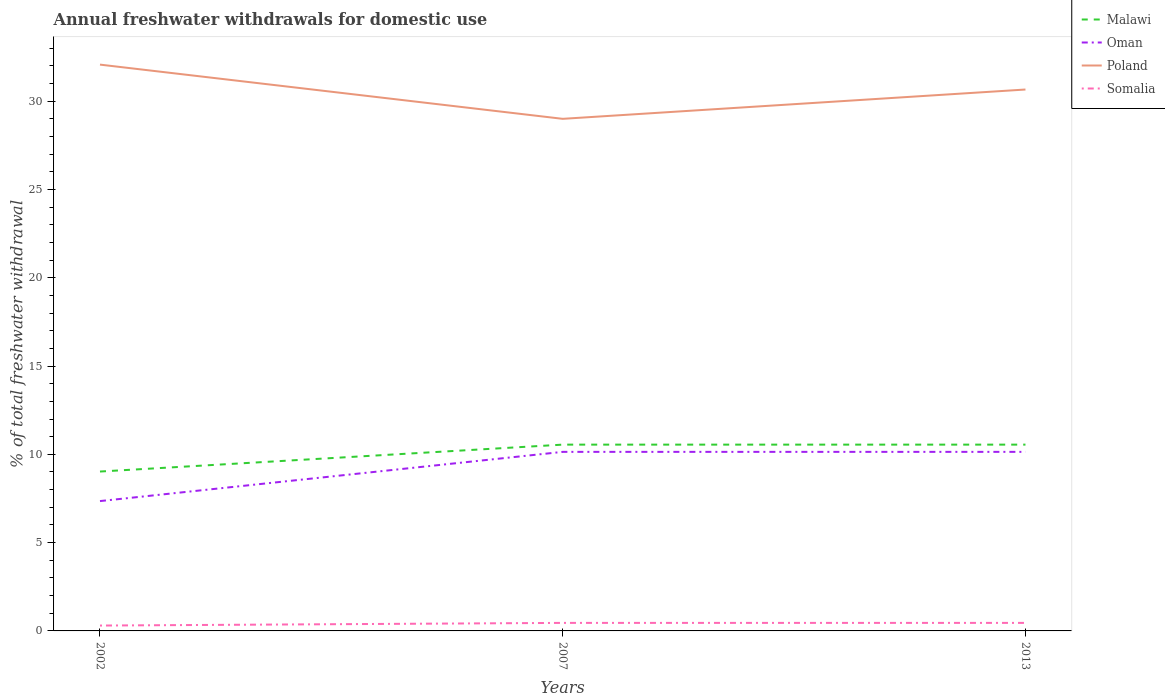Does the line corresponding to Poland intersect with the line corresponding to Oman?
Give a very brief answer. No. Is the number of lines equal to the number of legend labels?
Your answer should be very brief. Yes. Across all years, what is the maximum total annual withdrawals from freshwater in Somalia?
Your response must be concise. 0.3. In which year was the total annual withdrawals from freshwater in Malawi maximum?
Your answer should be compact. 2002. What is the difference between the highest and the second highest total annual withdrawals from freshwater in Somalia?
Your response must be concise. 0.15. Is the total annual withdrawals from freshwater in Malawi strictly greater than the total annual withdrawals from freshwater in Poland over the years?
Offer a very short reply. Yes. How many lines are there?
Keep it short and to the point. 4. Does the graph contain any zero values?
Offer a terse response. No. How are the legend labels stacked?
Provide a short and direct response. Vertical. What is the title of the graph?
Keep it short and to the point. Annual freshwater withdrawals for domestic use. Does "Tajikistan" appear as one of the legend labels in the graph?
Your answer should be very brief. No. What is the label or title of the X-axis?
Offer a terse response. Years. What is the label or title of the Y-axis?
Your answer should be compact. % of total freshwater withdrawal. What is the % of total freshwater withdrawal of Malawi in 2002?
Give a very brief answer. 9.03. What is the % of total freshwater withdrawal in Oman in 2002?
Ensure brevity in your answer.  7.35. What is the % of total freshwater withdrawal in Poland in 2002?
Give a very brief answer. 32.07. What is the % of total freshwater withdrawal in Somalia in 2002?
Ensure brevity in your answer.  0.3. What is the % of total freshwater withdrawal of Malawi in 2007?
Your answer should be compact. 10.55. What is the % of total freshwater withdrawal of Oman in 2007?
Make the answer very short. 10.14. What is the % of total freshwater withdrawal in Somalia in 2007?
Your response must be concise. 0.45. What is the % of total freshwater withdrawal of Malawi in 2013?
Your response must be concise. 10.55. What is the % of total freshwater withdrawal in Oman in 2013?
Ensure brevity in your answer.  10.14. What is the % of total freshwater withdrawal in Poland in 2013?
Your answer should be compact. 30.66. What is the % of total freshwater withdrawal of Somalia in 2013?
Provide a short and direct response. 0.45. Across all years, what is the maximum % of total freshwater withdrawal in Malawi?
Offer a very short reply. 10.55. Across all years, what is the maximum % of total freshwater withdrawal of Oman?
Offer a very short reply. 10.14. Across all years, what is the maximum % of total freshwater withdrawal in Poland?
Your answer should be compact. 32.07. Across all years, what is the maximum % of total freshwater withdrawal of Somalia?
Make the answer very short. 0.45. Across all years, what is the minimum % of total freshwater withdrawal in Malawi?
Keep it short and to the point. 9.03. Across all years, what is the minimum % of total freshwater withdrawal in Oman?
Offer a very short reply. 7.35. Across all years, what is the minimum % of total freshwater withdrawal of Somalia?
Give a very brief answer. 0.3. What is the total % of total freshwater withdrawal of Malawi in the graph?
Offer a terse response. 30.13. What is the total % of total freshwater withdrawal of Oman in the graph?
Give a very brief answer. 27.63. What is the total % of total freshwater withdrawal of Poland in the graph?
Provide a succinct answer. 91.73. What is the total % of total freshwater withdrawal in Somalia in the graph?
Ensure brevity in your answer.  1.21. What is the difference between the % of total freshwater withdrawal of Malawi in 2002 and that in 2007?
Your answer should be very brief. -1.52. What is the difference between the % of total freshwater withdrawal in Oman in 2002 and that in 2007?
Your answer should be compact. -2.79. What is the difference between the % of total freshwater withdrawal of Poland in 2002 and that in 2007?
Your answer should be compact. 3.07. What is the difference between the % of total freshwater withdrawal of Somalia in 2002 and that in 2007?
Ensure brevity in your answer.  -0.15. What is the difference between the % of total freshwater withdrawal in Malawi in 2002 and that in 2013?
Offer a very short reply. -1.52. What is the difference between the % of total freshwater withdrawal of Oman in 2002 and that in 2013?
Offer a very short reply. -2.79. What is the difference between the % of total freshwater withdrawal in Poland in 2002 and that in 2013?
Offer a very short reply. 1.41. What is the difference between the % of total freshwater withdrawal in Somalia in 2002 and that in 2013?
Your response must be concise. -0.15. What is the difference between the % of total freshwater withdrawal in Malawi in 2007 and that in 2013?
Provide a succinct answer. 0. What is the difference between the % of total freshwater withdrawal of Poland in 2007 and that in 2013?
Your answer should be compact. -1.66. What is the difference between the % of total freshwater withdrawal in Malawi in 2002 and the % of total freshwater withdrawal in Oman in 2007?
Your answer should be compact. -1.11. What is the difference between the % of total freshwater withdrawal in Malawi in 2002 and the % of total freshwater withdrawal in Poland in 2007?
Make the answer very short. -19.97. What is the difference between the % of total freshwater withdrawal in Malawi in 2002 and the % of total freshwater withdrawal in Somalia in 2007?
Provide a succinct answer. 8.57. What is the difference between the % of total freshwater withdrawal in Oman in 2002 and the % of total freshwater withdrawal in Poland in 2007?
Give a very brief answer. -21.65. What is the difference between the % of total freshwater withdrawal of Oman in 2002 and the % of total freshwater withdrawal of Somalia in 2007?
Keep it short and to the point. 6.9. What is the difference between the % of total freshwater withdrawal of Poland in 2002 and the % of total freshwater withdrawal of Somalia in 2007?
Keep it short and to the point. 31.62. What is the difference between the % of total freshwater withdrawal of Malawi in 2002 and the % of total freshwater withdrawal of Oman in 2013?
Make the answer very short. -1.11. What is the difference between the % of total freshwater withdrawal of Malawi in 2002 and the % of total freshwater withdrawal of Poland in 2013?
Provide a succinct answer. -21.63. What is the difference between the % of total freshwater withdrawal of Malawi in 2002 and the % of total freshwater withdrawal of Somalia in 2013?
Make the answer very short. 8.57. What is the difference between the % of total freshwater withdrawal of Oman in 2002 and the % of total freshwater withdrawal of Poland in 2013?
Offer a very short reply. -23.31. What is the difference between the % of total freshwater withdrawal in Oman in 2002 and the % of total freshwater withdrawal in Somalia in 2013?
Offer a terse response. 6.9. What is the difference between the % of total freshwater withdrawal of Poland in 2002 and the % of total freshwater withdrawal of Somalia in 2013?
Keep it short and to the point. 31.62. What is the difference between the % of total freshwater withdrawal of Malawi in 2007 and the % of total freshwater withdrawal of Oman in 2013?
Offer a terse response. 0.41. What is the difference between the % of total freshwater withdrawal in Malawi in 2007 and the % of total freshwater withdrawal in Poland in 2013?
Make the answer very short. -20.11. What is the difference between the % of total freshwater withdrawal of Malawi in 2007 and the % of total freshwater withdrawal of Somalia in 2013?
Provide a succinct answer. 10.1. What is the difference between the % of total freshwater withdrawal in Oman in 2007 and the % of total freshwater withdrawal in Poland in 2013?
Offer a terse response. -20.52. What is the difference between the % of total freshwater withdrawal of Oman in 2007 and the % of total freshwater withdrawal of Somalia in 2013?
Provide a short and direct response. 9.69. What is the difference between the % of total freshwater withdrawal in Poland in 2007 and the % of total freshwater withdrawal in Somalia in 2013?
Give a very brief answer. 28.55. What is the average % of total freshwater withdrawal in Malawi per year?
Offer a very short reply. 10.04. What is the average % of total freshwater withdrawal in Oman per year?
Ensure brevity in your answer.  9.21. What is the average % of total freshwater withdrawal of Poland per year?
Ensure brevity in your answer.  30.58. What is the average % of total freshwater withdrawal in Somalia per year?
Your response must be concise. 0.4. In the year 2002, what is the difference between the % of total freshwater withdrawal in Malawi and % of total freshwater withdrawal in Oman?
Your answer should be compact. 1.67. In the year 2002, what is the difference between the % of total freshwater withdrawal in Malawi and % of total freshwater withdrawal in Poland?
Your answer should be compact. -23.04. In the year 2002, what is the difference between the % of total freshwater withdrawal in Malawi and % of total freshwater withdrawal in Somalia?
Provide a short and direct response. 8.72. In the year 2002, what is the difference between the % of total freshwater withdrawal of Oman and % of total freshwater withdrawal of Poland?
Ensure brevity in your answer.  -24.72. In the year 2002, what is the difference between the % of total freshwater withdrawal of Oman and % of total freshwater withdrawal of Somalia?
Ensure brevity in your answer.  7.05. In the year 2002, what is the difference between the % of total freshwater withdrawal of Poland and % of total freshwater withdrawal of Somalia?
Ensure brevity in your answer.  31.77. In the year 2007, what is the difference between the % of total freshwater withdrawal in Malawi and % of total freshwater withdrawal in Oman?
Offer a terse response. 0.41. In the year 2007, what is the difference between the % of total freshwater withdrawal in Malawi and % of total freshwater withdrawal in Poland?
Give a very brief answer. -18.45. In the year 2007, what is the difference between the % of total freshwater withdrawal in Malawi and % of total freshwater withdrawal in Somalia?
Make the answer very short. 10.1. In the year 2007, what is the difference between the % of total freshwater withdrawal in Oman and % of total freshwater withdrawal in Poland?
Your answer should be compact. -18.86. In the year 2007, what is the difference between the % of total freshwater withdrawal of Oman and % of total freshwater withdrawal of Somalia?
Make the answer very short. 9.69. In the year 2007, what is the difference between the % of total freshwater withdrawal in Poland and % of total freshwater withdrawal in Somalia?
Your answer should be compact. 28.55. In the year 2013, what is the difference between the % of total freshwater withdrawal in Malawi and % of total freshwater withdrawal in Oman?
Give a very brief answer. 0.41. In the year 2013, what is the difference between the % of total freshwater withdrawal of Malawi and % of total freshwater withdrawal of Poland?
Make the answer very short. -20.11. In the year 2013, what is the difference between the % of total freshwater withdrawal of Malawi and % of total freshwater withdrawal of Somalia?
Ensure brevity in your answer.  10.1. In the year 2013, what is the difference between the % of total freshwater withdrawal of Oman and % of total freshwater withdrawal of Poland?
Your answer should be very brief. -20.52. In the year 2013, what is the difference between the % of total freshwater withdrawal of Oman and % of total freshwater withdrawal of Somalia?
Your response must be concise. 9.69. In the year 2013, what is the difference between the % of total freshwater withdrawal in Poland and % of total freshwater withdrawal in Somalia?
Provide a succinct answer. 30.21. What is the ratio of the % of total freshwater withdrawal in Malawi in 2002 to that in 2007?
Ensure brevity in your answer.  0.86. What is the ratio of the % of total freshwater withdrawal of Oman in 2002 to that in 2007?
Make the answer very short. 0.73. What is the ratio of the % of total freshwater withdrawal of Poland in 2002 to that in 2007?
Ensure brevity in your answer.  1.11. What is the ratio of the % of total freshwater withdrawal in Somalia in 2002 to that in 2007?
Offer a very short reply. 0.67. What is the ratio of the % of total freshwater withdrawal of Malawi in 2002 to that in 2013?
Make the answer very short. 0.86. What is the ratio of the % of total freshwater withdrawal of Oman in 2002 to that in 2013?
Keep it short and to the point. 0.73. What is the ratio of the % of total freshwater withdrawal of Poland in 2002 to that in 2013?
Keep it short and to the point. 1.05. What is the ratio of the % of total freshwater withdrawal of Somalia in 2002 to that in 2013?
Provide a succinct answer. 0.67. What is the ratio of the % of total freshwater withdrawal of Poland in 2007 to that in 2013?
Your response must be concise. 0.95. What is the difference between the highest and the second highest % of total freshwater withdrawal of Poland?
Make the answer very short. 1.41. What is the difference between the highest and the lowest % of total freshwater withdrawal in Malawi?
Make the answer very short. 1.52. What is the difference between the highest and the lowest % of total freshwater withdrawal of Oman?
Your answer should be compact. 2.79. What is the difference between the highest and the lowest % of total freshwater withdrawal in Poland?
Offer a terse response. 3.07. What is the difference between the highest and the lowest % of total freshwater withdrawal in Somalia?
Make the answer very short. 0.15. 